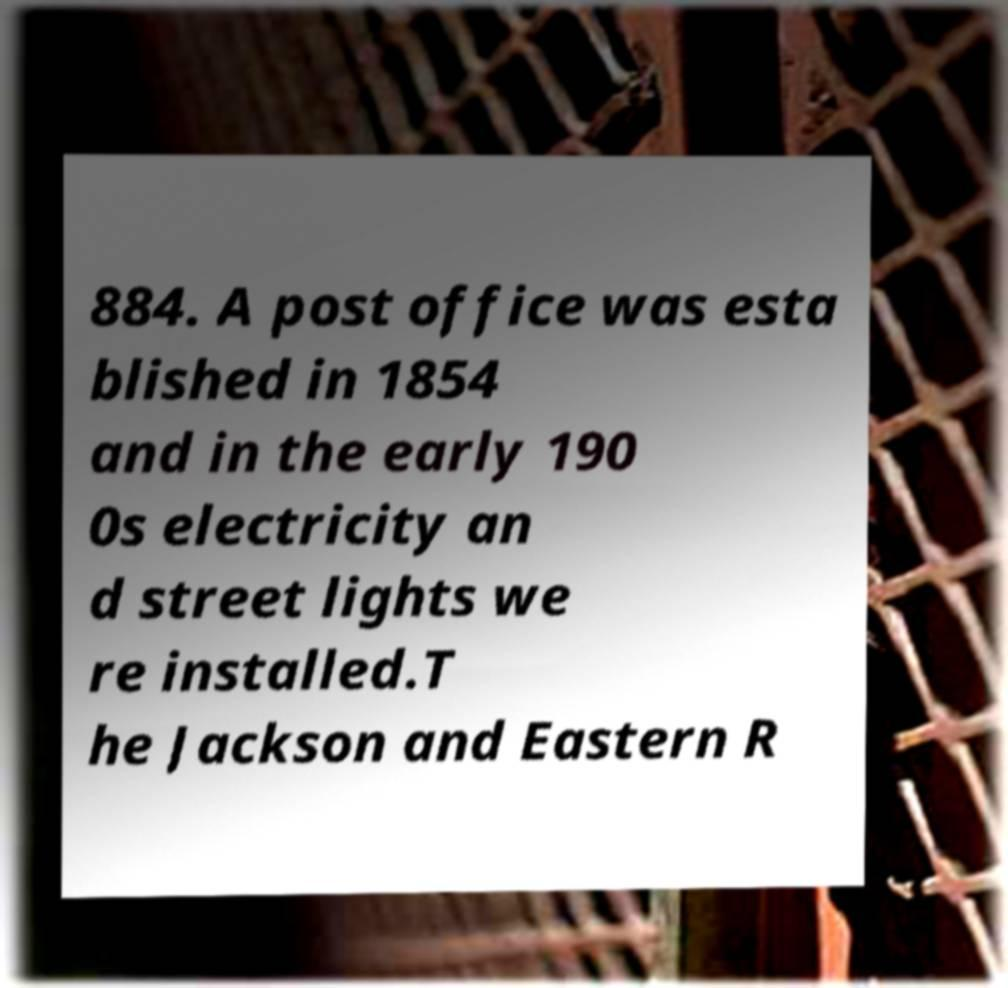There's text embedded in this image that I need extracted. Can you transcribe it verbatim? 884. A post office was esta blished in 1854 and in the early 190 0s electricity an d street lights we re installed.T he Jackson and Eastern R 